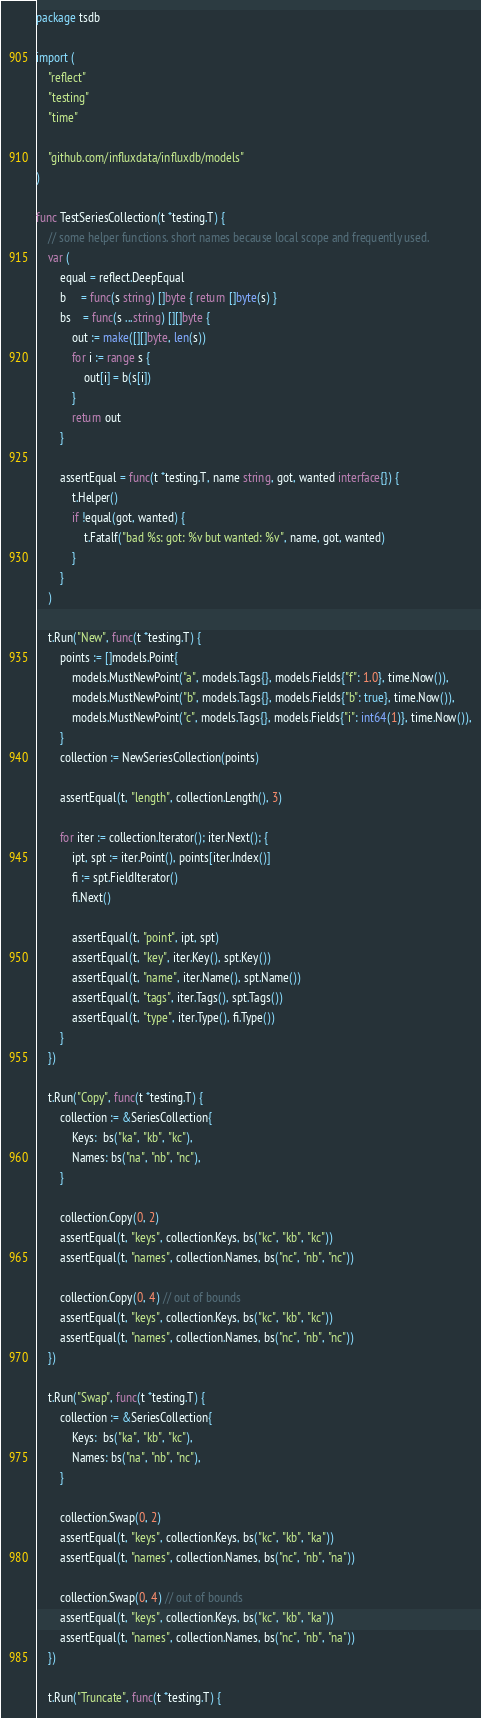<code> <loc_0><loc_0><loc_500><loc_500><_Go_>package tsdb

import (
	"reflect"
	"testing"
	"time"

	"github.com/influxdata/influxdb/models"
)

func TestSeriesCollection(t *testing.T) {
	// some helper functions. short names because local scope and frequently used.
	var (
		equal = reflect.DeepEqual
		b     = func(s string) []byte { return []byte(s) }
		bs    = func(s ...string) [][]byte {
			out := make([][]byte, len(s))
			for i := range s {
				out[i] = b(s[i])
			}
			return out
		}

		assertEqual = func(t *testing.T, name string, got, wanted interface{}) {
			t.Helper()
			if !equal(got, wanted) {
				t.Fatalf("bad %s: got: %v but wanted: %v", name, got, wanted)
			}
		}
	)

	t.Run("New", func(t *testing.T) {
		points := []models.Point{
			models.MustNewPoint("a", models.Tags{}, models.Fields{"f": 1.0}, time.Now()),
			models.MustNewPoint("b", models.Tags{}, models.Fields{"b": true}, time.Now()),
			models.MustNewPoint("c", models.Tags{}, models.Fields{"i": int64(1)}, time.Now()),
		}
		collection := NewSeriesCollection(points)

		assertEqual(t, "length", collection.Length(), 3)

		for iter := collection.Iterator(); iter.Next(); {
			ipt, spt := iter.Point(), points[iter.Index()]
			fi := spt.FieldIterator()
			fi.Next()

			assertEqual(t, "point", ipt, spt)
			assertEqual(t, "key", iter.Key(), spt.Key())
			assertEqual(t, "name", iter.Name(), spt.Name())
			assertEqual(t, "tags", iter.Tags(), spt.Tags())
			assertEqual(t, "type", iter.Type(), fi.Type())
		}
	})

	t.Run("Copy", func(t *testing.T) {
		collection := &SeriesCollection{
			Keys:  bs("ka", "kb", "kc"),
			Names: bs("na", "nb", "nc"),
		}

		collection.Copy(0, 2)
		assertEqual(t, "keys", collection.Keys, bs("kc", "kb", "kc"))
		assertEqual(t, "names", collection.Names, bs("nc", "nb", "nc"))

		collection.Copy(0, 4) // out of bounds
		assertEqual(t, "keys", collection.Keys, bs("kc", "kb", "kc"))
		assertEqual(t, "names", collection.Names, bs("nc", "nb", "nc"))
	})

	t.Run("Swap", func(t *testing.T) {
		collection := &SeriesCollection{
			Keys:  bs("ka", "kb", "kc"),
			Names: bs("na", "nb", "nc"),
		}

		collection.Swap(0, 2)
		assertEqual(t, "keys", collection.Keys, bs("kc", "kb", "ka"))
		assertEqual(t, "names", collection.Names, bs("nc", "nb", "na"))

		collection.Swap(0, 4) // out of bounds
		assertEqual(t, "keys", collection.Keys, bs("kc", "kb", "ka"))
		assertEqual(t, "names", collection.Names, bs("nc", "nb", "na"))
	})

	t.Run("Truncate", func(t *testing.T) {</code> 